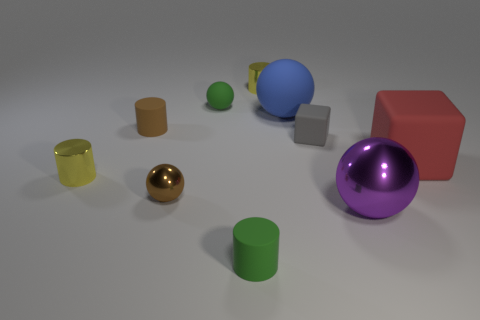Subtract 2 cylinders. How many cylinders are left? 2 Subtract all blue spheres. How many spheres are left? 3 Subtract all balls. How many objects are left? 6 Subtract all green spheres. How many spheres are left? 3 Subtract 0 cyan blocks. How many objects are left? 10 Subtract all red spheres. Subtract all green cylinders. How many spheres are left? 4 Subtract all brown cylinders. How many red spheres are left? 0 Subtract all big blue balls. Subtract all tiny green matte things. How many objects are left? 7 Add 7 big matte spheres. How many big matte spheres are left? 8 Add 8 big red matte spheres. How many big red matte spheres exist? 8 